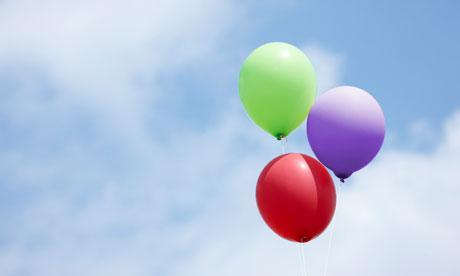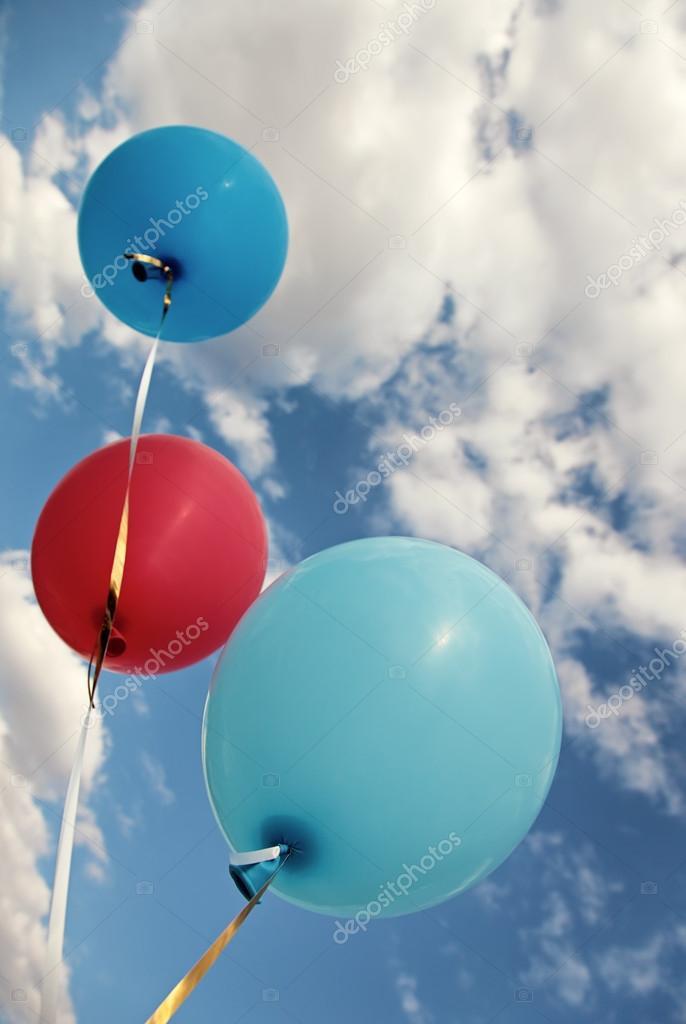The first image is the image on the left, the second image is the image on the right. Evaluate the accuracy of this statement regarding the images: "Three balloons the same color and attached to strings are in one image, while a second image shows three balloons of different colors.". Is it true? Answer yes or no. No. The first image is the image on the left, the second image is the image on the right. Given the left and right images, does the statement "There is at least two red balloons." hold true? Answer yes or no. Yes. 